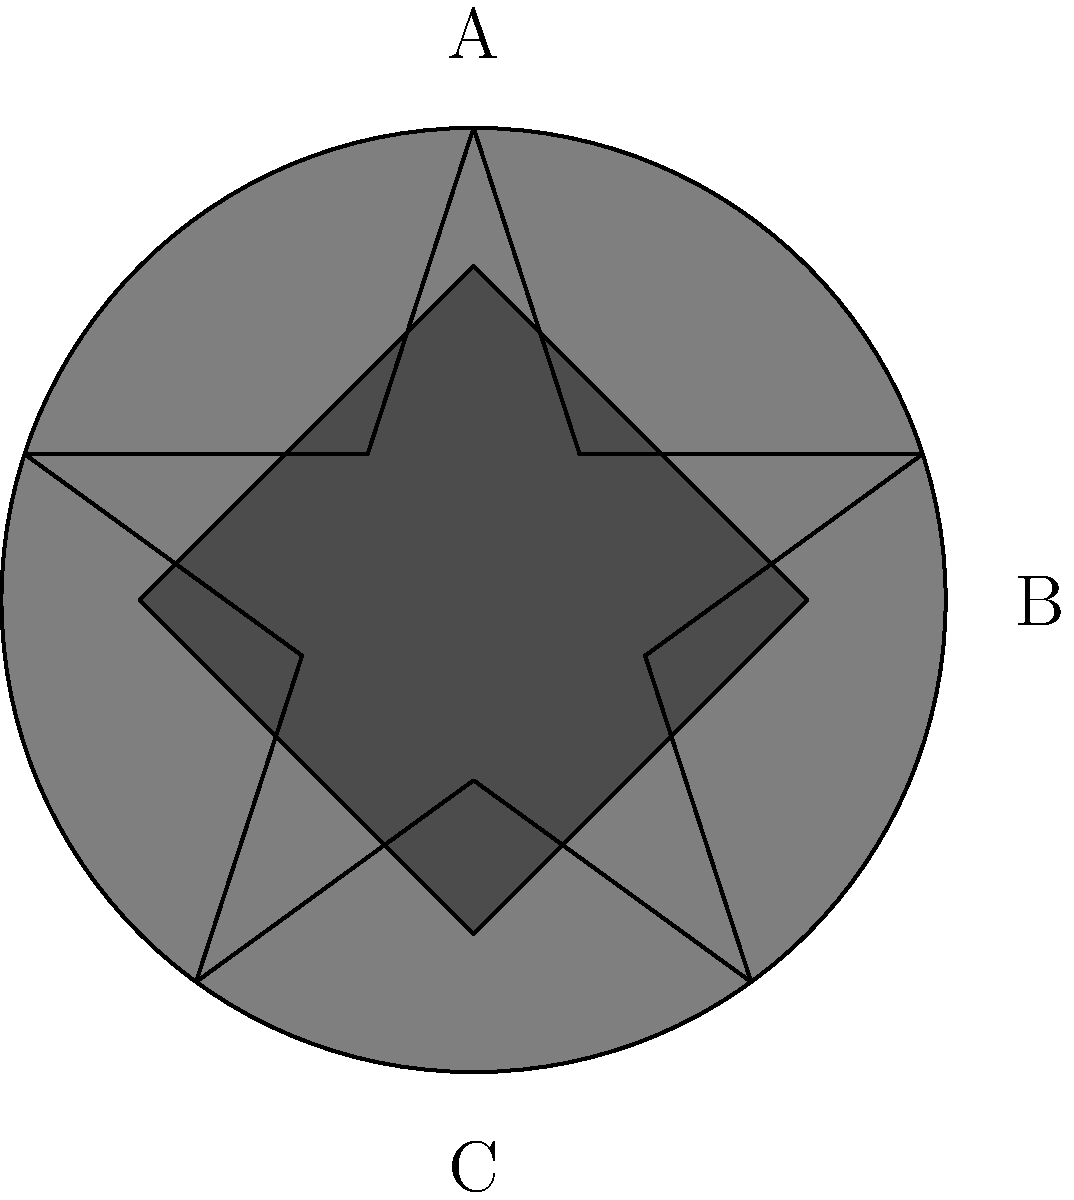As a government policy analyst, you're reviewing military insignia for a veteran support program. The image shows three puzzle pieces representing different military symbols. Which arrangement of these pieces would correctly form the U.S. Army logo, with the star at the top, the eagle in the middle, and the anchor at the bottom? To solve this puzzle, we need to analyze the given pieces and their potential arrangement:

1. The U.S. Army logo consists of three main elements: a star at the top, an eagle in the middle, and a shield (which resembles an anchor) at the bottom.

2. Piece A is a five-pointed star, which matches the top element of the Army logo.

3. Piece B is an eagle silhouette, which corresponds to the middle element of the logo.

4. Piece C is a diamond-shaped anchor, which can represent the shield at the bottom of the logo.

5. The correct arrangement from top to bottom would be:
   - Star (A)
   - Eagle (B)
   - Anchor/Shield (C)

Therefore, the correct arrangement of the pieces to form the U.S. Army logo is A-B-C, with A at the top, B in the middle, and C at the bottom.
Answer: A-B-C 